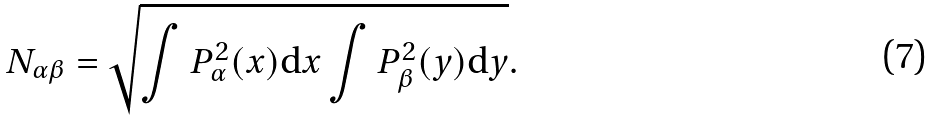Convert formula to latex. <formula><loc_0><loc_0><loc_500><loc_500>N _ { \alpha \beta } = \sqrt { \int P ^ { 2 } _ { \alpha } ( x ) \mathrm d x \int P ^ { 2 } _ { \beta } ( y ) \mathrm d y } .</formula> 